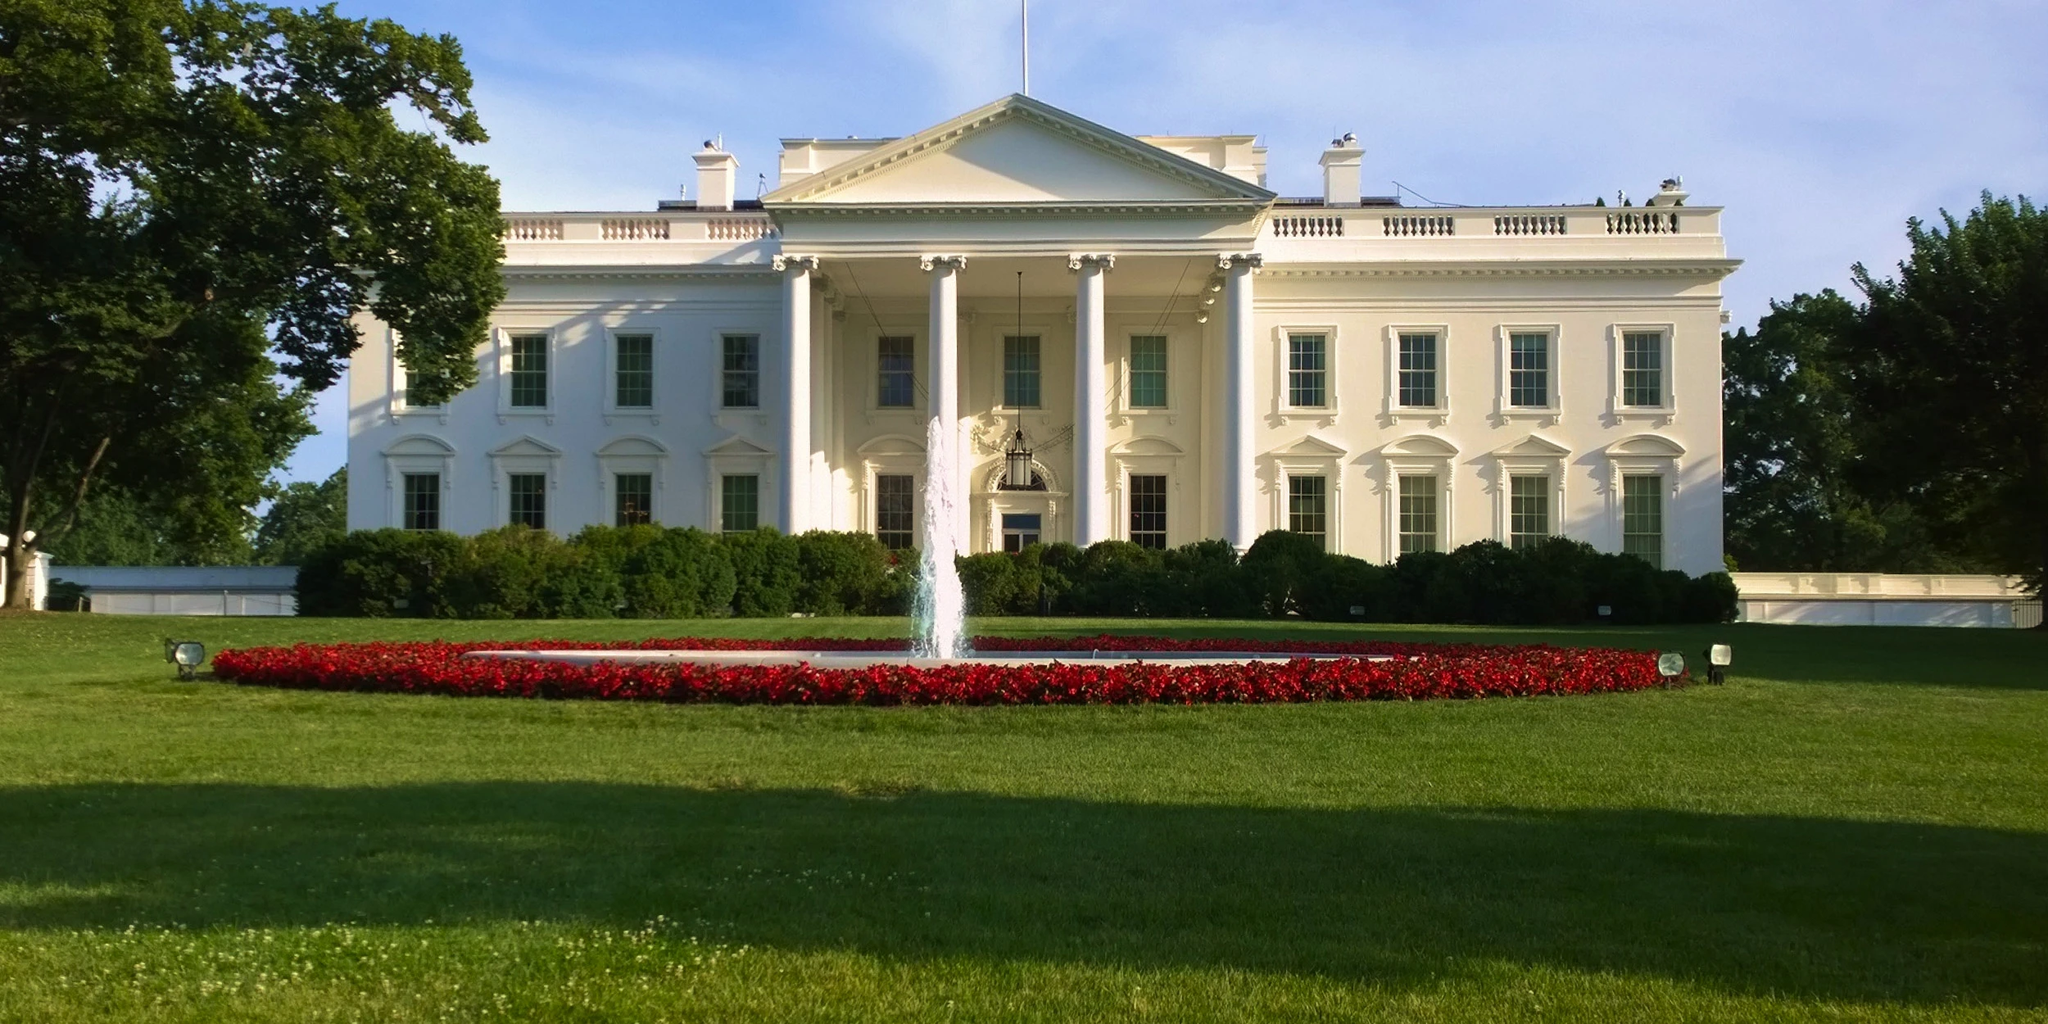Imagine if the fountain in front of the White House was enchanted and could grant one wish every year. What kind of wishes do you think would be made? If the fountain in front of the White House were enchanted to grant one wish every year, the possibilities for wishes would be both intriguing and diverse. The President might wish for solutions to pressing global issues like peace, climate change, or poverty. Key officials could wish for the well-being and prosperity of the nation. Perhaps there would be more whimsical wishes too, like ensuring perpetual harmony in the White House garden or endowing the residence with a cultural renaissance that brings art and history to life. Such an enchanted fountain would become a symbol of hope and possibility, captured in the heart of a historic and powerful site. 